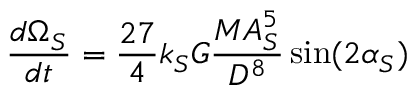Convert formula to latex. <formula><loc_0><loc_0><loc_500><loc_500>{ \frac { d \Omega _ { S } } { d t } } = { \frac { 2 7 } { 4 } } k _ { S } G { \frac { M A _ { S } ^ { 5 } } { D ^ { 8 } } } \sin ( 2 \alpha _ { S } )</formula> 